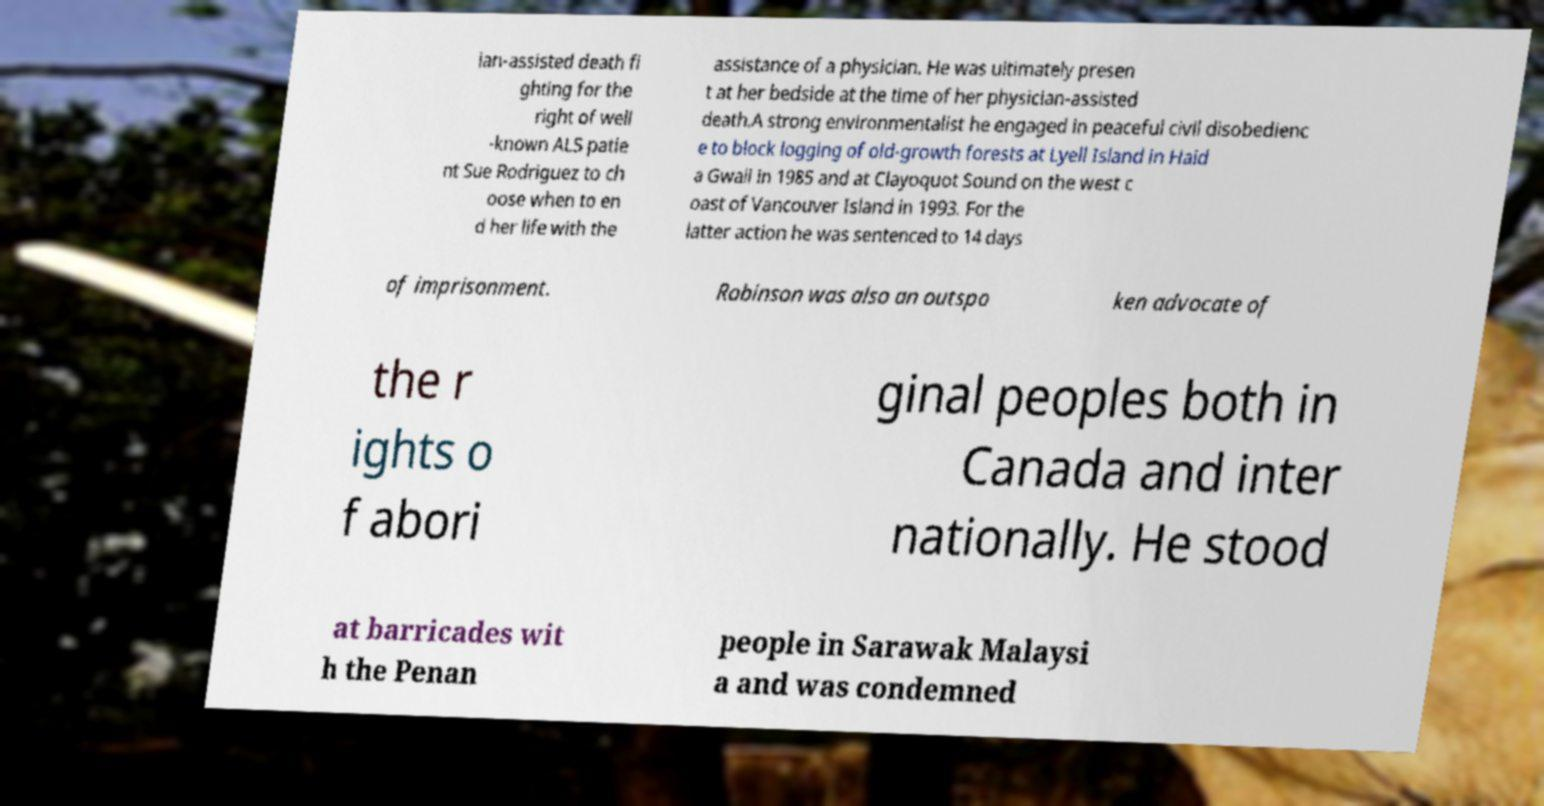Could you extract and type out the text from this image? ian-assisted death fi ghting for the right of well -known ALS patie nt Sue Rodriguez to ch oose when to en d her life with the assistance of a physician. He was ultimately presen t at her bedside at the time of her physician-assisted death.A strong environmentalist he engaged in peaceful civil disobedienc e to block logging of old-growth forests at Lyell Island in Haid a Gwaii in 1985 and at Clayoquot Sound on the west c oast of Vancouver Island in 1993. For the latter action he was sentenced to 14 days of imprisonment. Robinson was also an outspo ken advocate of the r ights o f abori ginal peoples both in Canada and inter nationally. He stood at barricades wit h the Penan people in Sarawak Malaysi a and was condemned 